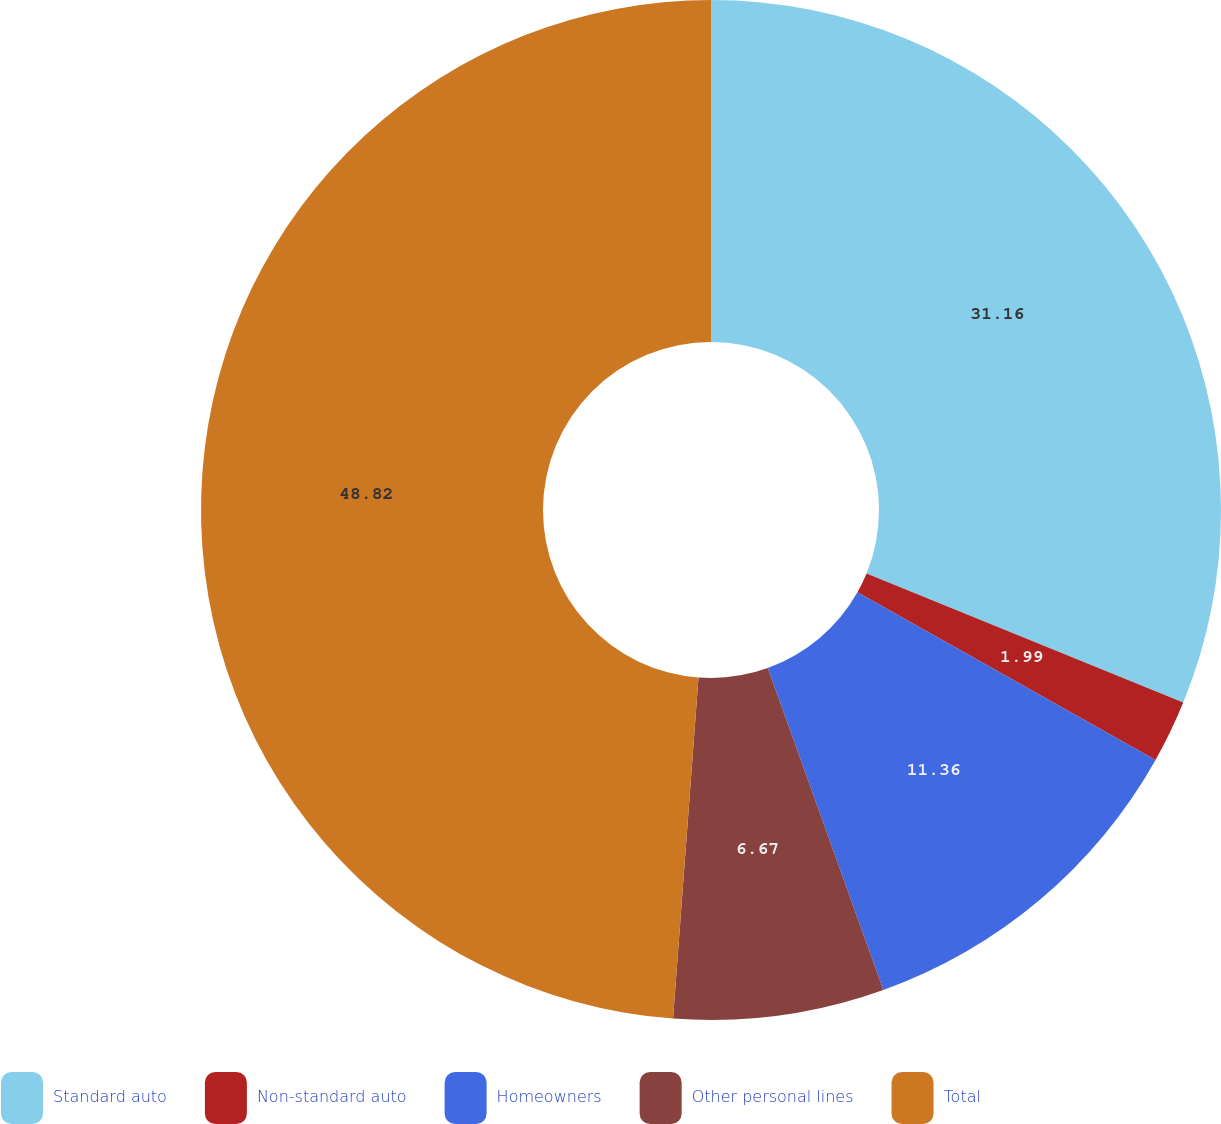Convert chart. <chart><loc_0><loc_0><loc_500><loc_500><pie_chart><fcel>Standard auto<fcel>Non-standard auto<fcel>Homeowners<fcel>Other personal lines<fcel>Total<nl><fcel>31.16%<fcel>1.99%<fcel>11.36%<fcel>6.67%<fcel>48.81%<nl></chart> 